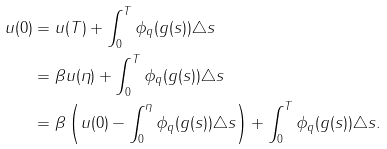Convert formula to latex. <formula><loc_0><loc_0><loc_500><loc_500>u ( 0 ) & = u ( T ) + \int _ { 0 } ^ { T } \phi _ { q } ( g ( s ) ) \triangle s \\ & = \beta u ( \eta ) + \int _ { 0 } ^ { T } \phi _ { q } ( g ( s ) ) \triangle s \\ & = \beta \left ( u ( 0 ) - \int _ { 0 } ^ { \eta } \phi _ { q } ( g ( s ) ) \triangle s \right ) + \int _ { 0 } ^ { T } \phi _ { q } ( g ( s ) ) \triangle s .</formula> 